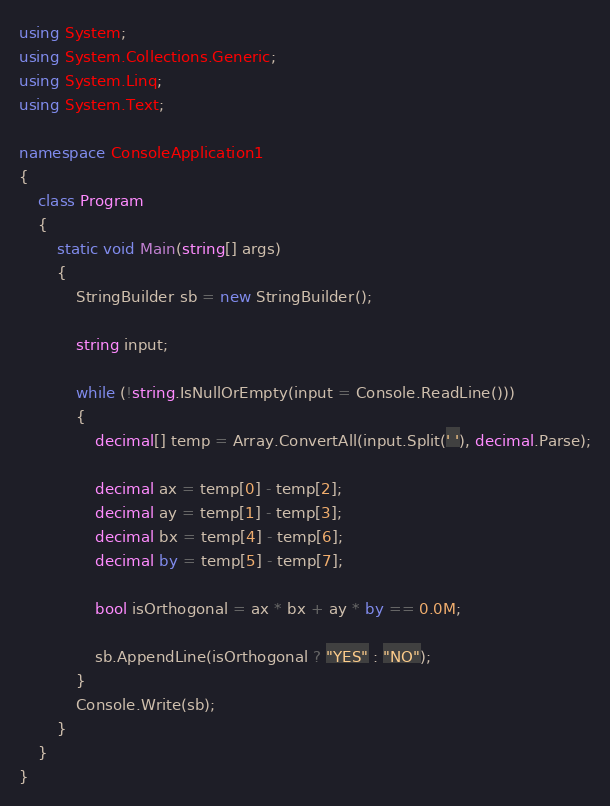Convert code to text. <code><loc_0><loc_0><loc_500><loc_500><_C#_>using System;
using System.Collections.Generic;
using System.Linq;
using System.Text;

namespace ConsoleApplication1
{
    class Program
    {
        static void Main(string[] args)
        {
            StringBuilder sb = new StringBuilder();

            string input;

            while (!string.IsNullOrEmpty(input = Console.ReadLine()))
            {
                decimal[] temp = Array.ConvertAll(input.Split(' '), decimal.Parse);

                decimal ax = temp[0] - temp[2];
                decimal ay = temp[1] - temp[3];
                decimal bx = temp[4] - temp[6];
                decimal by = temp[5] - temp[7];

                bool isOrthogonal = ax * bx + ay * by == 0.0M;

                sb.AppendLine(isOrthogonal ? "YES" : "NO");
            }
            Console.Write(sb);
        }
    }
}</code> 